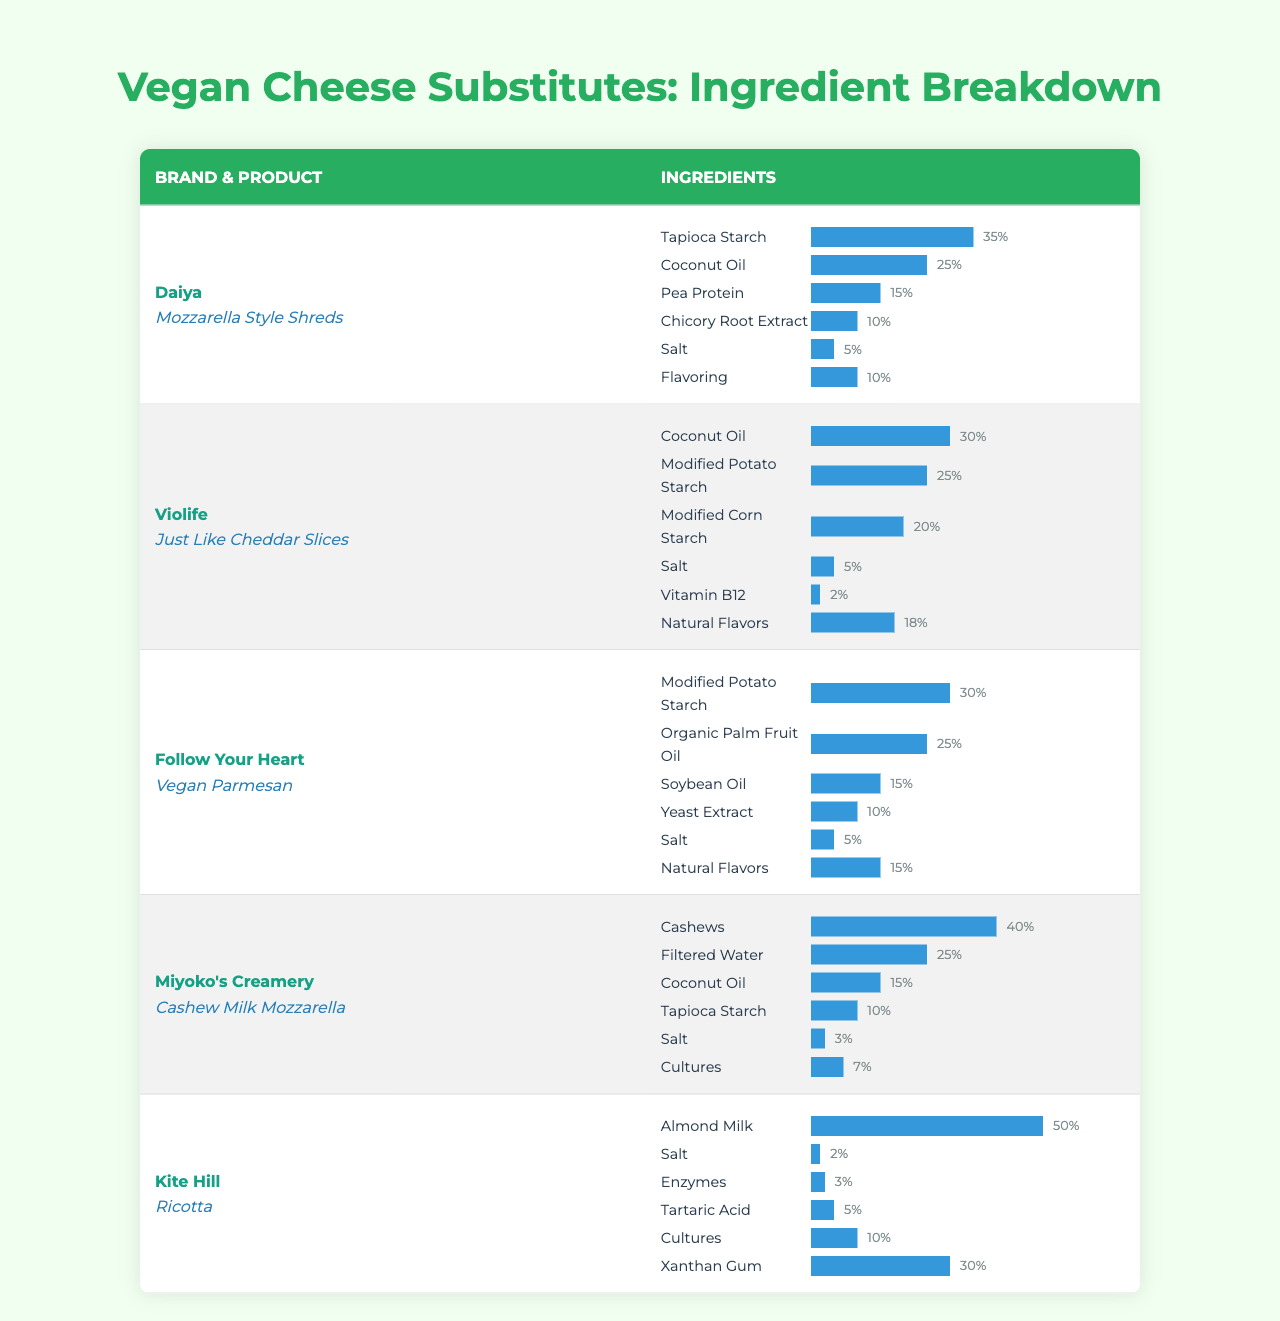What is the ingredient with the highest percentage in Daiya's Mozzarella Style Shreds? The table shows that the highest percentage ingredient in Daiya's Mozzarella Style Shreds is Tapioca Starch, which comprises 35% of the product.
Answer: Tapioca Starch Which vegan cheese substitute has the least amount of salt in its ingredients? In the table, Kite Hill's Ricotta contains only 2% salt, which is less than the other products listed.
Answer: Kite Hill's Ricotta What are the total percentages of non-oil bases in Miyoko's Creamery Cashew Milk Mozzarella? The non-oil bases in Miyoko's are Cashews (40%), Filtered Water (25%), Tapioca Starch (10%), and Cultures (7%). Adding these up, 40 + 25 + 10 + 7 = 82%.
Answer: 82% Is the ingredient Coconut Oil present in all the vegan cheese substitutes listed? The table indicates that Coconut Oil is present in Daiya, Violife, and Miyoko's products, but not in Follow Your Heart or Kite Hill. Therefore, the statement is false.
Answer: No Which brand has the highest percentage of a single ingredient and what is that ingredient? Upon reviewing the table, Kite Hill has the highest single ingredient percentage at 50% with Almond Milk.
Answer: Kite Hill (Almond Milk) Calculate the average percentage of Coconut Oil across all brands. The percentages of Coconut Oil are: Daiya (25%), Violife (30%), Follow Your Heart (none), Miyoko's (15%), and Kite Hill (none). The average is calculated as (25 + 30 + 15) / 3 = 23.33%.
Answer: 23.33% Are there any products that contain both Coconut Oil and Salt? In the table, both Daiya's Mozzarella Style Shreds and Miyoko's Cashew Milk Mozzarella contain Coconut Oil and Salt, verifying that the statement is true.
Answer: Yes What percentage of ingredients in Follow Your Heart's Vegan Parmesan are flavor-related? For Follow Your Heart, the ingredients Natural Flavors (15%) and Yeast Extract (10%) can be considered flavor-related, totaling 25%.
Answer: 25% Which product uses Modified Potato Starch as its primary ingredient, and what is its percentage? The Follow Your Heart Vegan Parmesan uses Modified Potato Starch as its primary ingredient at 30%.
Answer: Follow Your Heart (30%) If Daiya's Mozzarella Style Shreds were to decrease its Chicory Root Extract by 5%, what would the new percentage be? Currently, Chicory Root Extract is at 10%. If it decreases by 5%, it would be 10 - 5 = 5%.
Answer: 5% 